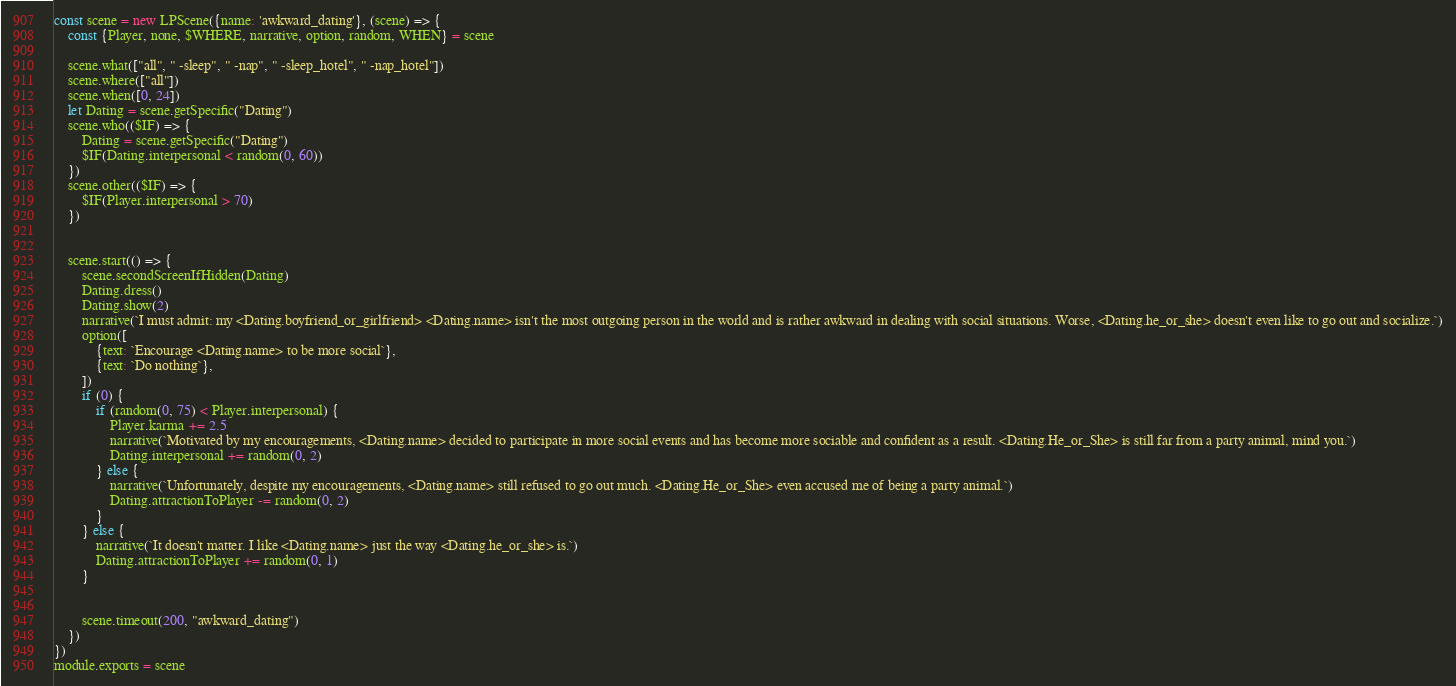<code> <loc_0><loc_0><loc_500><loc_500><_JavaScript_>const scene = new LPScene({name: 'awkward_dating'}, (scene) => {
    const {Player, none, $WHERE, narrative, option, random, WHEN} = scene

    scene.what(["all", " -sleep", " -nap", " -sleep_hotel", " -nap_hotel"])
    scene.where(["all"])
    scene.when([0, 24])
    let Dating = scene.getSpecific("Dating")
    scene.who(($IF) => {
        Dating = scene.getSpecific("Dating")
        $IF(Dating.interpersonal < random(0, 60))
    })
    scene.other(($IF) => {
        $IF(Player.interpersonal > 70)
    })


    scene.start(() => {
        scene.secondScreenIfHidden(Dating)
        Dating.dress()
        Dating.show(2)
        narrative(`I must admit: my <Dating.boyfriend_or_girlfriend> <Dating.name> isn't the most outgoing person in the world and is rather awkward in dealing with social situations. Worse, <Dating.he_or_she> doesn't even like to go out and socialize.`)
        option([
            {text: `Encourage <Dating.name> to be more social`},
            {text: `Do nothing`},
        ])
        if (0) {
            if (random(0, 75) < Player.interpersonal) {
                Player.karma += 2.5
                narrative(`Motivated by my encouragements, <Dating.name> decided to participate in more social events and has become more sociable and confident as a result. <Dating.He_or_She> is still far from a party animal, mind you.`)
                Dating.interpersonal += random(0, 2)
            } else {
                narrative(`Unfortunately, despite my encouragements, <Dating.name> still refused to go out much. <Dating.He_or_She> even accused me of being a party animal.`)
                Dating.attractionToPlayer -= random(0, 2)
            }
        } else {
            narrative(`It doesn't matter. I like <Dating.name> just the way <Dating.he_or_she> is.`)
            Dating.attractionToPlayer += random(0, 1)
        }


        scene.timeout(200, "awkward_dating")
    })
})
module.exports = scene</code> 